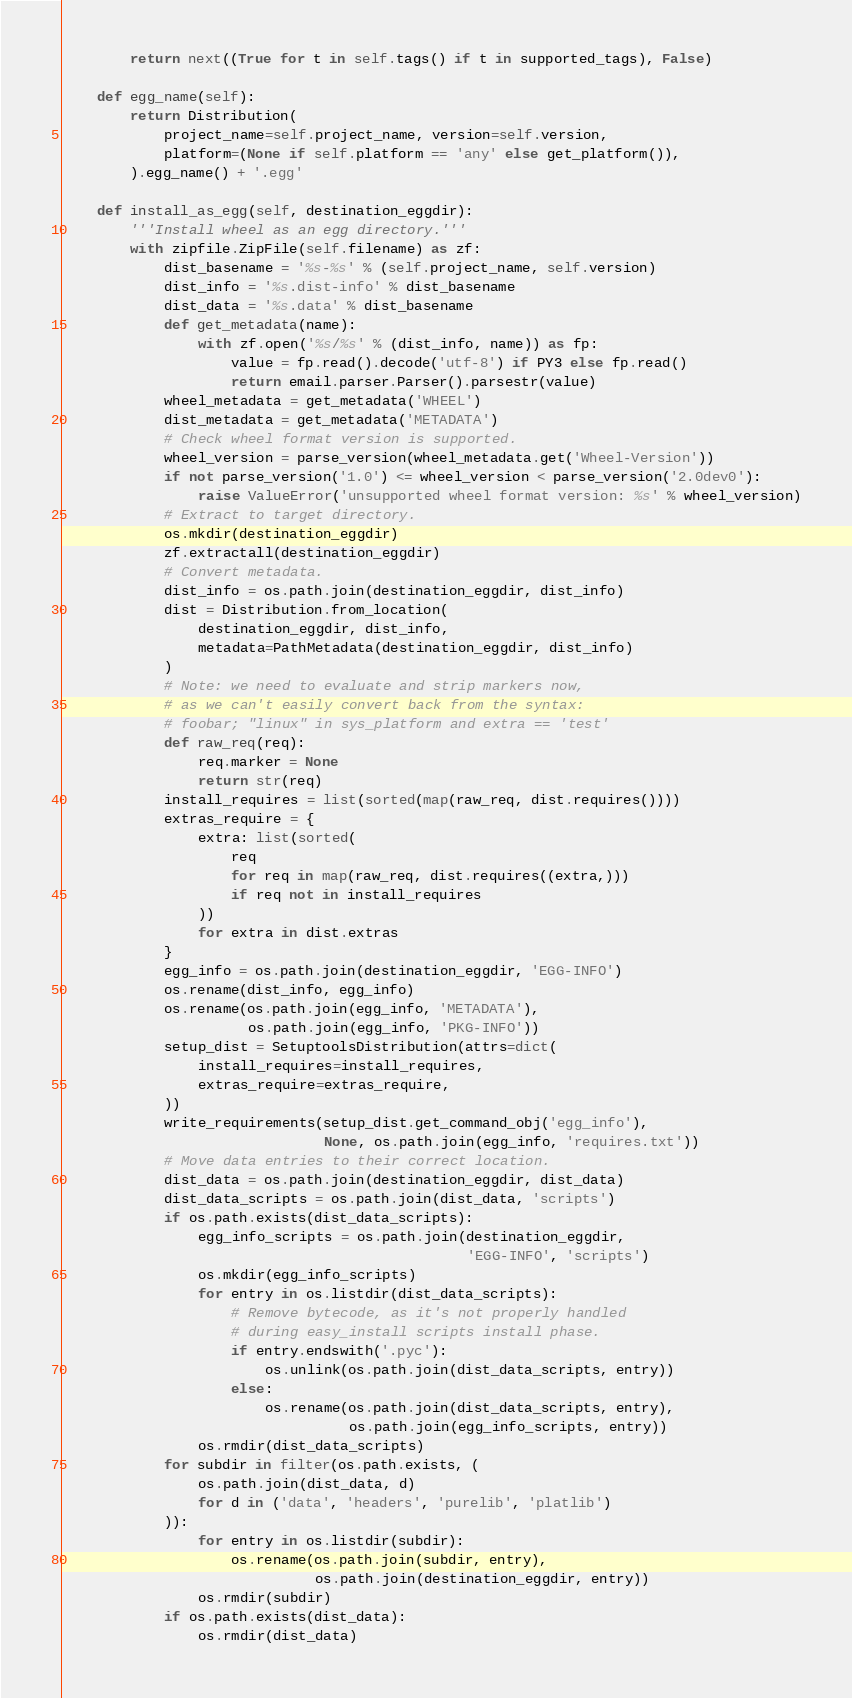Convert code to text. <code><loc_0><loc_0><loc_500><loc_500><_Python_>        return next((True for t in self.tags() if t in supported_tags), False)

    def egg_name(self):
        return Distribution(
            project_name=self.project_name, version=self.version,
            platform=(None if self.platform == 'any' else get_platform()),
        ).egg_name() + '.egg'

    def install_as_egg(self, destination_eggdir):
        '''Install wheel as an egg directory.'''
        with zipfile.ZipFile(self.filename) as zf:
            dist_basename = '%s-%s' % (self.project_name, self.version)
            dist_info = '%s.dist-info' % dist_basename
            dist_data = '%s.data' % dist_basename
            def get_metadata(name):
                with zf.open('%s/%s' % (dist_info, name)) as fp:
                    value = fp.read().decode('utf-8') if PY3 else fp.read()
                    return email.parser.Parser().parsestr(value)
            wheel_metadata = get_metadata('WHEEL')
            dist_metadata = get_metadata('METADATA')
            # Check wheel format version is supported.
            wheel_version = parse_version(wheel_metadata.get('Wheel-Version'))
            if not parse_version('1.0') <= wheel_version < parse_version('2.0dev0'):
                raise ValueError('unsupported wheel format version: %s' % wheel_version)
            # Extract to target directory.
            os.mkdir(destination_eggdir)
            zf.extractall(destination_eggdir)
            # Convert metadata.
            dist_info = os.path.join(destination_eggdir, dist_info)
            dist = Distribution.from_location(
                destination_eggdir, dist_info,
                metadata=PathMetadata(destination_eggdir, dist_info)
            )
            # Note: we need to evaluate and strip markers now,
            # as we can't easily convert back from the syntax:
            # foobar; "linux" in sys_platform and extra == 'test'
            def raw_req(req):
                req.marker = None
                return str(req)
            install_requires = list(sorted(map(raw_req, dist.requires())))
            extras_require = {
                extra: list(sorted(
                    req
                    for req in map(raw_req, dist.requires((extra,)))
                    if req not in install_requires
                ))
                for extra in dist.extras
            }
            egg_info = os.path.join(destination_eggdir, 'EGG-INFO')
            os.rename(dist_info, egg_info)
            os.rename(os.path.join(egg_info, 'METADATA'),
                      os.path.join(egg_info, 'PKG-INFO'))
            setup_dist = SetuptoolsDistribution(attrs=dict(
                install_requires=install_requires,
                extras_require=extras_require,
            ))
            write_requirements(setup_dist.get_command_obj('egg_info'),
                               None, os.path.join(egg_info, 'requires.txt'))
            # Move data entries to their correct location.
            dist_data = os.path.join(destination_eggdir, dist_data)
            dist_data_scripts = os.path.join(dist_data, 'scripts')
            if os.path.exists(dist_data_scripts):
                egg_info_scripts = os.path.join(destination_eggdir,
                                                'EGG-INFO', 'scripts')
                os.mkdir(egg_info_scripts)
                for entry in os.listdir(dist_data_scripts):
                    # Remove bytecode, as it's not properly handled
                    # during easy_install scripts install phase.
                    if entry.endswith('.pyc'):
                        os.unlink(os.path.join(dist_data_scripts, entry))
                    else:
                        os.rename(os.path.join(dist_data_scripts, entry),
                                  os.path.join(egg_info_scripts, entry))
                os.rmdir(dist_data_scripts)
            for subdir in filter(os.path.exists, (
                os.path.join(dist_data, d)
                for d in ('data', 'headers', 'purelib', 'platlib')
            )):
                for entry in os.listdir(subdir):
                    os.rename(os.path.join(subdir, entry),
                              os.path.join(destination_eggdir, entry))
                os.rmdir(subdir)
            if os.path.exists(dist_data):
                os.rmdir(dist_data)
</code> 